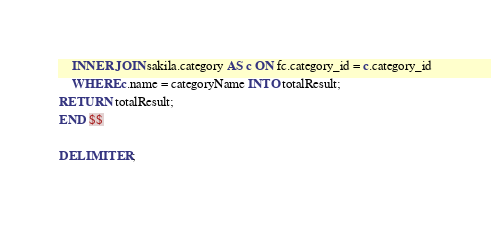<code> <loc_0><loc_0><loc_500><loc_500><_SQL_>	INNER JOIN sakila.category AS c ON fc.category_id = c.category_id
	WHERE c.name = categoryName INTO totalResult;
RETURN totalResult;
END $$

DELIMITER ;</code> 